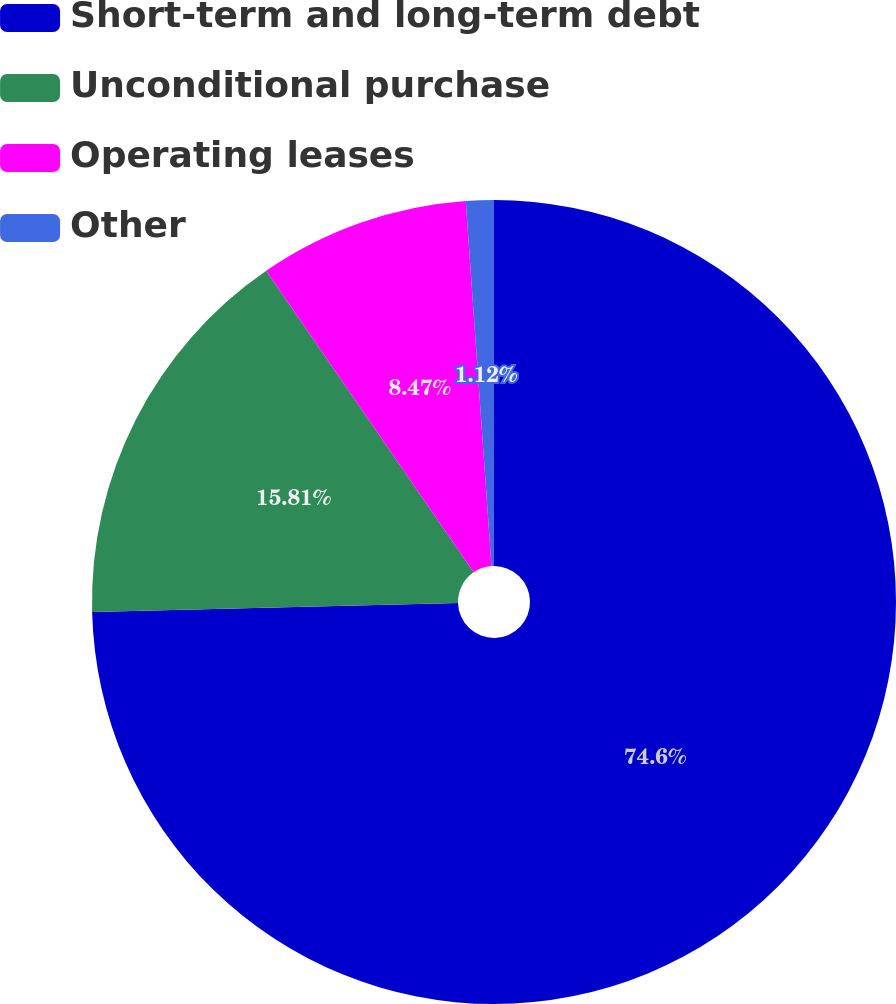Convert chart. <chart><loc_0><loc_0><loc_500><loc_500><pie_chart><fcel>Short-term and long-term debt<fcel>Unconditional purchase<fcel>Operating leases<fcel>Other<nl><fcel>74.6%<fcel>15.81%<fcel>8.47%<fcel>1.12%<nl></chart> 